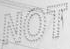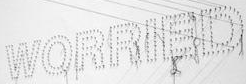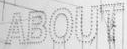Read the text from these images in sequence, separated by a semicolon. NOT; WORRIED; ABOUT 